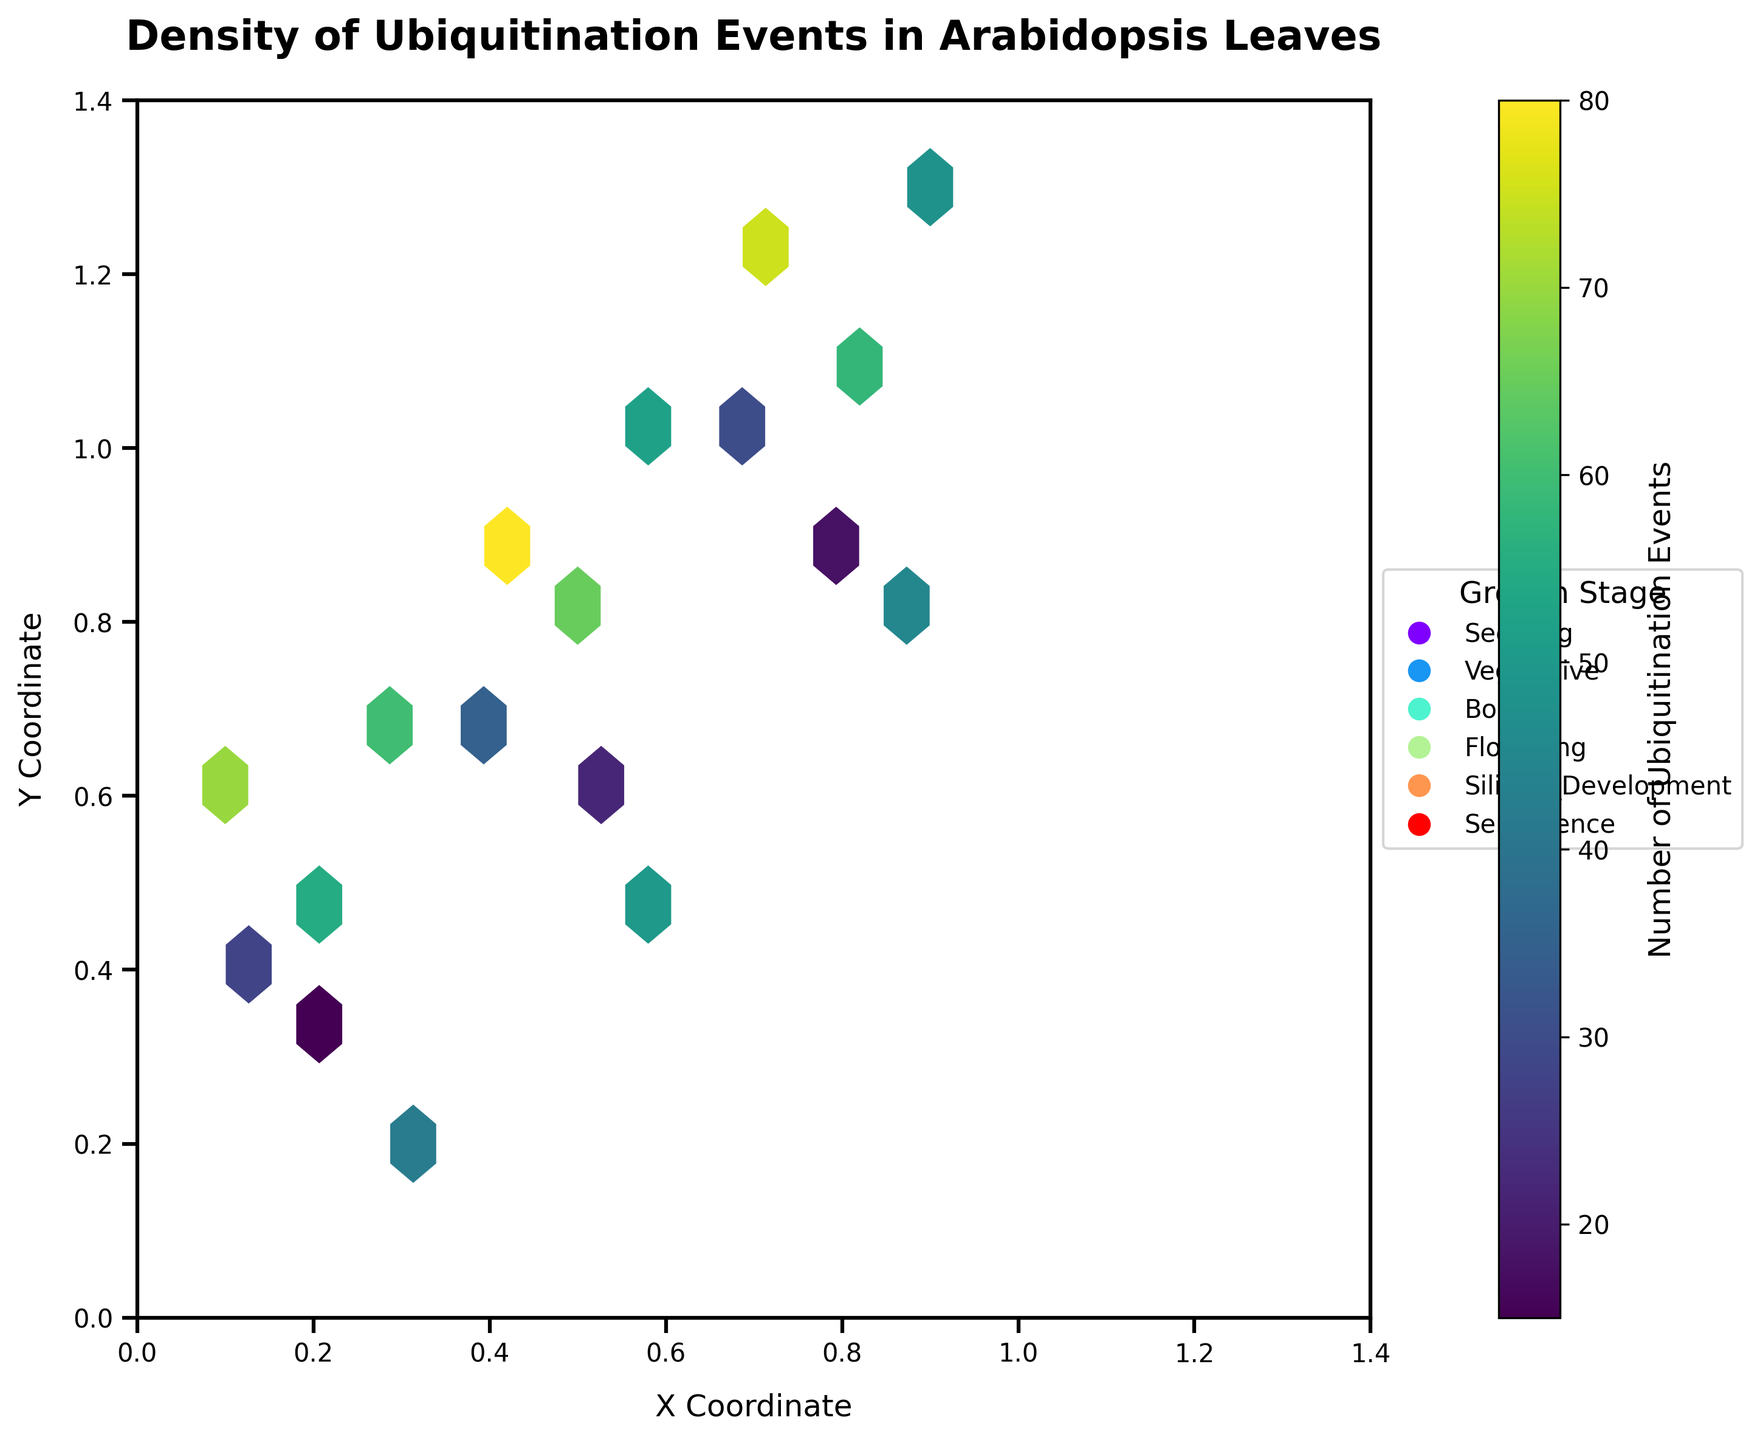What's the title of the plot? The title is usually located at the top of the plot and directly displays the main topic. In this case, it can be read clearly.
Answer: Density of Ubiquitination Events in Arabidopsis Leaves What is the x-axis label? The x-axis label is shown below the horizontal axis. It indicates what the x-values represent in the plot.
Answer: X Coordinate What is the y-axis label? The y-axis label is positioned next to the vertical axis, indicating what the y-values represent.
Answer: Y Coordinate What does the color bar represent? The color bar is usually located beside the plot and shows the range of values. It provides information about the variable represented by the color intensity. In this case, it indicates the number of ubiquitination events.
Answer: Number of Ubiquitination Events Which growth stage has the highest density of ubiquitination events? To determine this, look at the plot and find the hexbin cells with the darkest color, which indicates the highest density, then refer to the growth stage legend to identify the corresponding stage.
Answer: Silique Development How do the densities of ubiquitination events compare between Vegetative and Flowering stages? Compare the color intensities of the hexbins associated with each growth stage. The stage with darker hexbins indicates higher densities. Flowering has consistently darker hexbins than Vegetative, showing a higher density of ubiquitination events.
Answer: Flowering has higher density At what coordinates do the highest ubiquitination events occur during the Flowering stage? Look for the hexbins with the highest color intensity within the Flowering stage, which are around the coordinates where these dark hexbins are centered. These coordinates are approximately at (0.5, 0.8).
Answer: (0.5, 0.8) What does the grid size parameter affect in the hexbin plot? The grid size determines how many hexbins are used to divide the space. A larger grid size means more, smaller hexbins and finer detail; a smaller grid size means fewer, larger hexbins and coarser detail. This can influence how densely packed the hexbins appear.
Answer: The fineness of the division Which stage shows ubiquitination events most uniformly distributed across the coordinates? Look for the growth stage with hexbins of similar color intensity spread over a wide range of coordinates. The Flowering stage shows a more uniform distribution of dense hexbins across multiple coordinates.
Answer: Flowering stage Which growth stage shows ubiquitination at the (0.1, 0.6) coordinate? Locate the coordinate in the plot and check the corresponding hexbins. Then refer to the growth stage legend to identify the color. The stages with any darkened hexbins at (0.1, 0.6) coordinate are the Silique Development stage.
Answer: Silique Development 